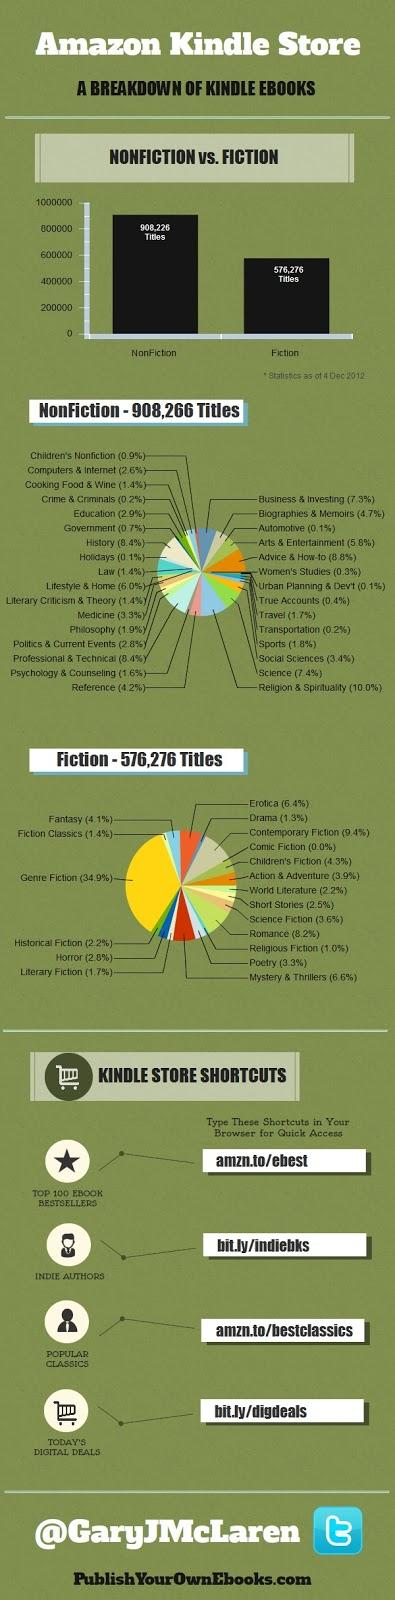Draw attention to some important aspects in this diagram. The automotive, urban planning and development, and related genres had the lowest percentage of books written in the non-fiction category. In 2012, non-fiction titles outsold fiction titles by 331,950 copies. According to the data, the Advice & How-to genre of non-fiction had the highest percentage of books published. According to the data, Contemporary Fiction was the fiction genre that had the second highest percentage of books written. 